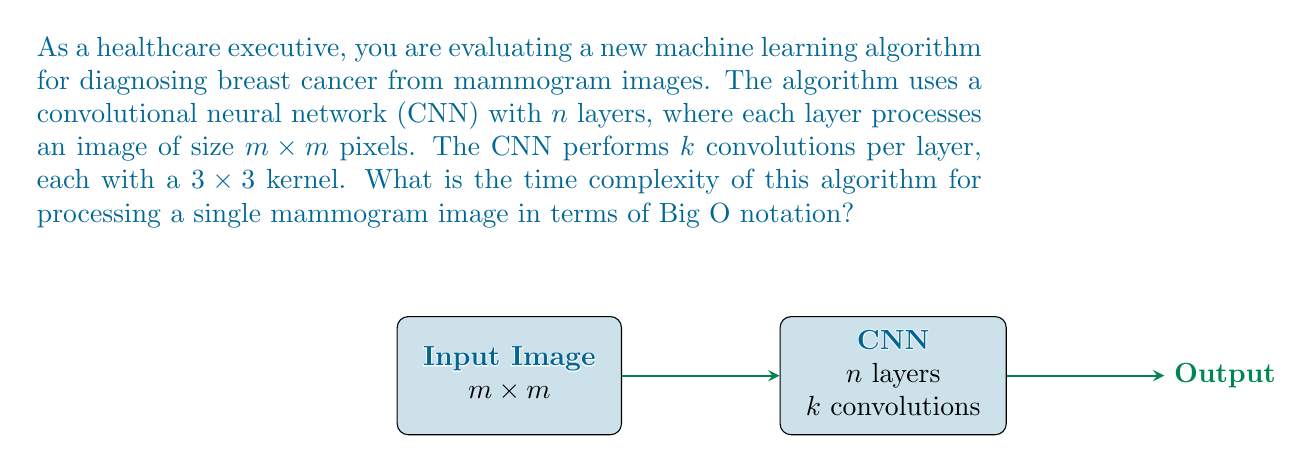Show me your answer to this math problem. To determine the time complexity, let's break down the algorithm's operations:

1) The CNN has $n$ layers, so we need to process the image $n$ times.

2) In each layer, we perform $k$ convolutions.

3) Each convolution operates on the entire $m \times m$ image using a $3 \times 3$ kernel.

4) For a single $3 \times 3$ convolution on an $m \times m$ image, we need to perform:
   - $3 \times 3 = 9$ multiplications
   - 8 additions (to sum the products)
   - This operation is done for each of the $m^2$ pixels

5) Therefore, for a single convolution, the number of operations is:
   $$(9 + 8) \times m^2 = 17m^2$$

6) For $k$ convolutions in a single layer:
   $$k \times 17m^2 = 17km^2$$

7) For $n$ layers:
   $$n \times 17km^2 = 17nkm^2$$

8) The constant factors and lower-order terms are dropped in Big O notation.

Therefore, the time complexity of this algorithm for processing a single mammogram image is $O(nkm^2)$.
Answer: $O(nkm^2)$ 